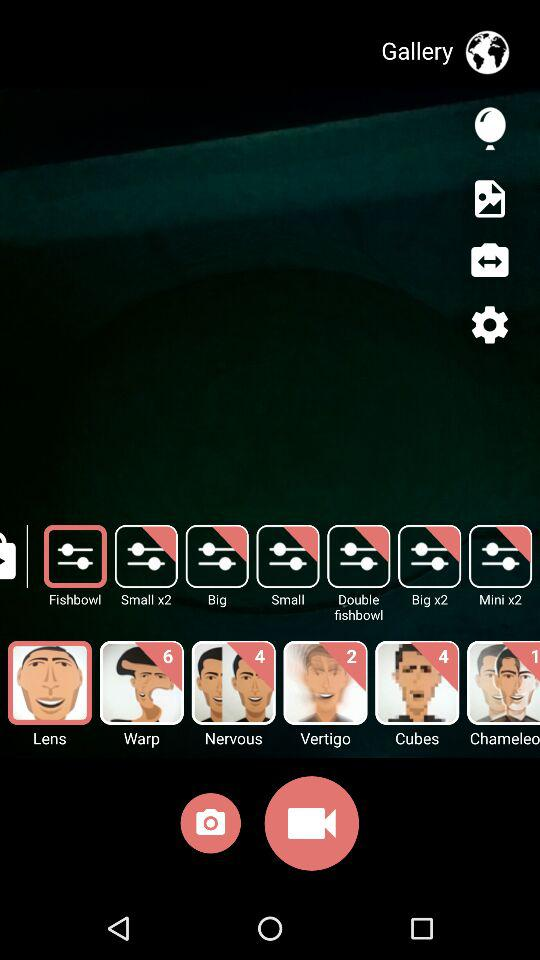4 new features for which option?
When the provided information is insufficient, respond with <no answer>. <no answer> 